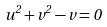Convert formula to latex. <formula><loc_0><loc_0><loc_500><loc_500>u ^ { 2 } + v ^ { 2 } - v = 0</formula> 